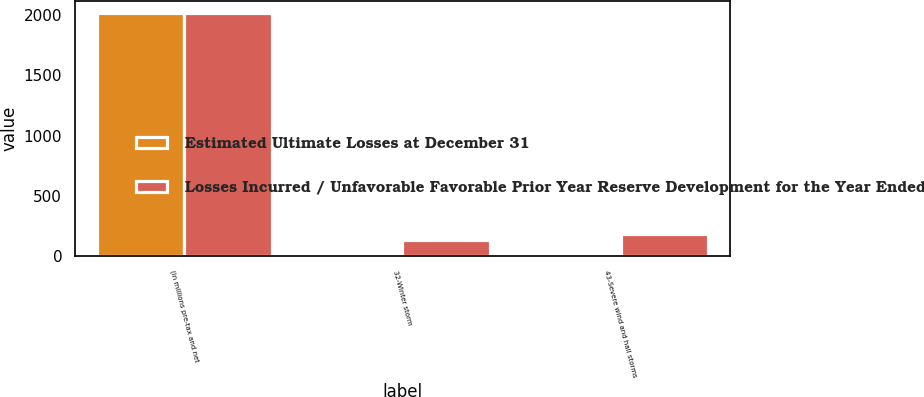Convert chart to OTSL. <chart><loc_0><loc_0><loc_500><loc_500><stacked_bar_chart><ecel><fcel>(in millions pre-tax and net<fcel>32-Winter storm<fcel>43-Severe wind and hail storms<nl><fcel>Estimated Ultimate Losses at December 31<fcel>2016<fcel>1<fcel>5<nl><fcel>Losses Incurred / Unfavorable Favorable Prior Year Reserve Development for the Year Ended December 31<fcel>2016<fcel>138<fcel>181<nl></chart> 